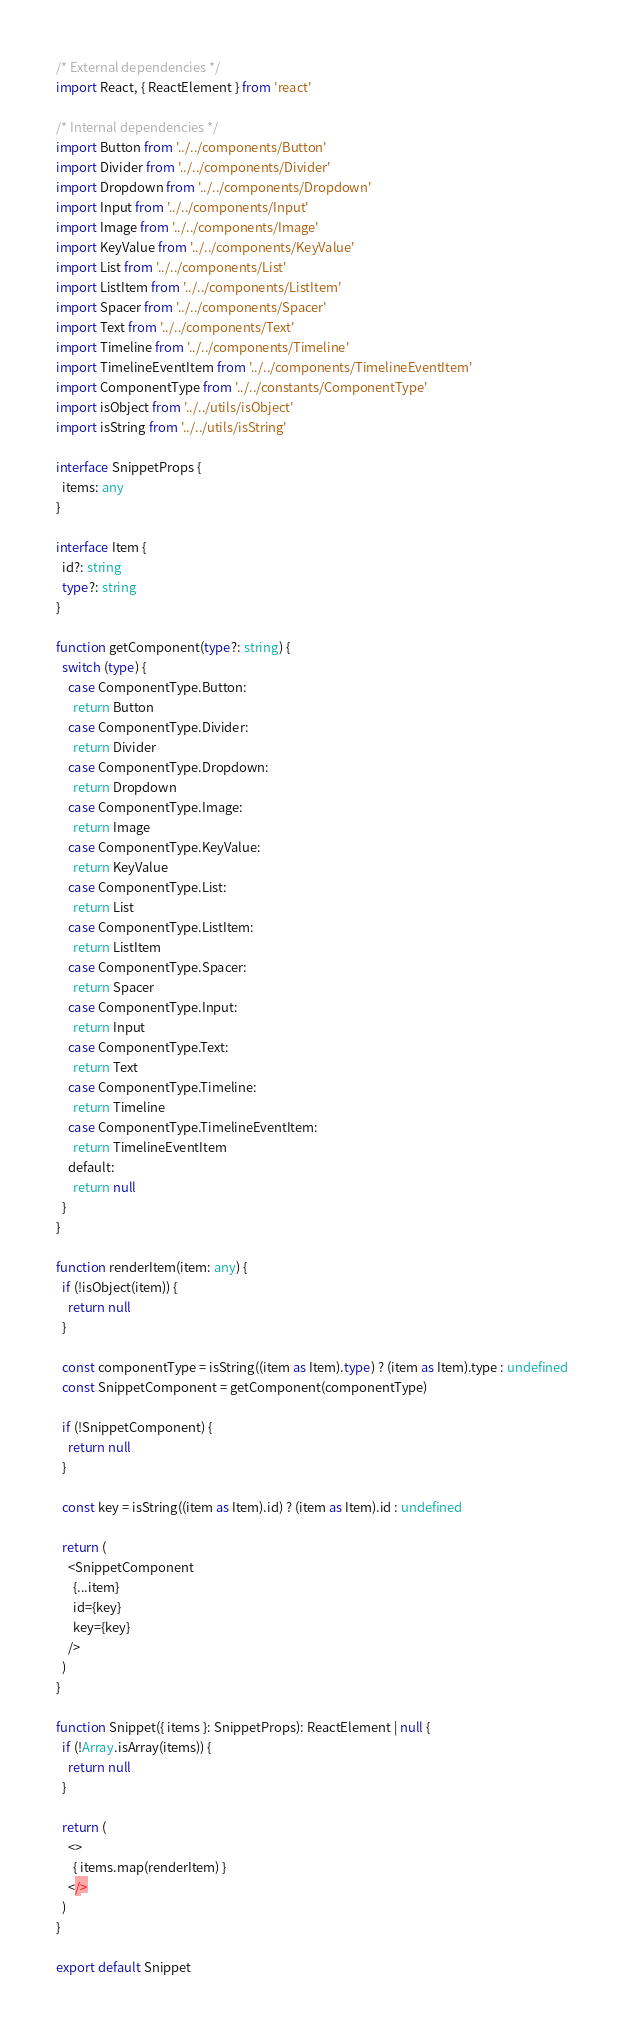<code> <loc_0><loc_0><loc_500><loc_500><_TypeScript_>/* External dependencies */
import React, { ReactElement } from 'react'

/* Internal dependencies */
import Button from '../../components/Button'
import Divider from '../../components/Divider'
import Dropdown from '../../components/Dropdown'
import Input from '../../components/Input'
import Image from '../../components/Image'
import KeyValue from '../../components/KeyValue'
import List from '../../components/List'
import ListItem from '../../components/ListItem'
import Spacer from '../../components/Spacer'
import Text from '../../components/Text'
import Timeline from '../../components/Timeline'
import TimelineEventItem from '../../components/TimelineEventItem'
import ComponentType from '../../constants/ComponentType'
import isObject from '../../utils/isObject'
import isString from '../../utils/isString'

interface SnippetProps {
  items: any
}

interface Item {
  id?: string
  type?: string
}

function getComponent(type?: string) {
  switch (type) {
    case ComponentType.Button:
      return Button
    case ComponentType.Divider:
      return Divider
    case ComponentType.Dropdown:
      return Dropdown
    case ComponentType.Image:
      return Image
    case ComponentType.KeyValue:
      return KeyValue
    case ComponentType.List:
      return List
    case ComponentType.ListItem:
      return ListItem
    case ComponentType.Spacer:
      return Spacer
    case ComponentType.Input:
      return Input
    case ComponentType.Text:
      return Text
    case ComponentType.Timeline:
      return Timeline
    case ComponentType.TimelineEventItem:
      return TimelineEventItem
    default:
      return null
  }
}

function renderItem(item: any) {
  if (!isObject(item)) {
    return null
  }

  const componentType = isString((item as Item).type) ? (item as Item).type : undefined
  const SnippetComponent = getComponent(componentType)

  if (!SnippetComponent) {
    return null
  }

  const key = isString((item as Item).id) ? (item as Item).id : undefined

  return (
    <SnippetComponent
      {...item}
      id={key}
      key={key}
    />
  )
}

function Snippet({ items }: SnippetProps): ReactElement | null {
  if (!Array.isArray(items)) {
    return null
  }

  return (
    <>
      { items.map(renderItem) }
    </>
  )
}

export default Snippet
</code> 